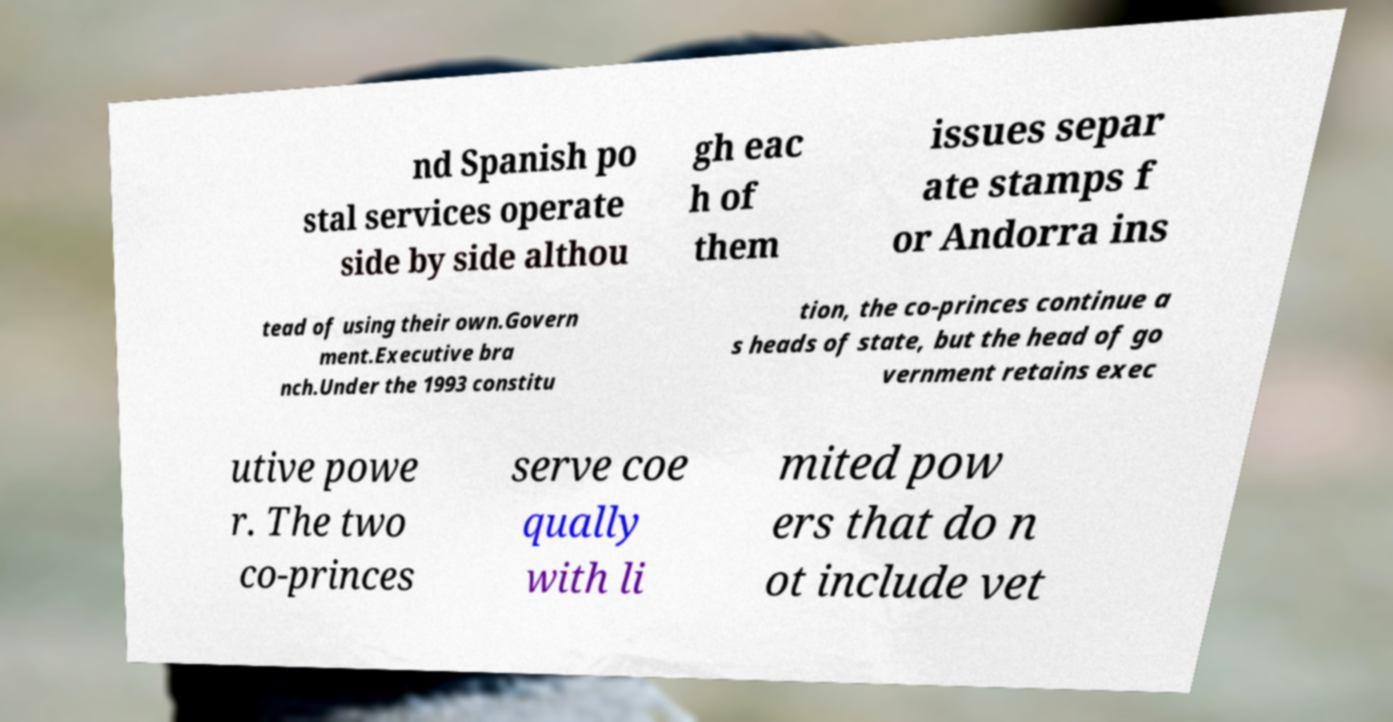Can you read and provide the text displayed in the image?This photo seems to have some interesting text. Can you extract and type it out for me? nd Spanish po stal services operate side by side althou gh eac h of them issues separ ate stamps f or Andorra ins tead of using their own.Govern ment.Executive bra nch.Under the 1993 constitu tion, the co-princes continue a s heads of state, but the head of go vernment retains exec utive powe r. The two co-princes serve coe qually with li mited pow ers that do n ot include vet 